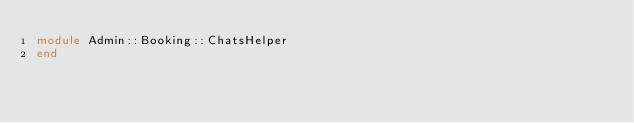Convert code to text. <code><loc_0><loc_0><loc_500><loc_500><_Ruby_>module Admin::Booking::ChatsHelper
end
</code> 